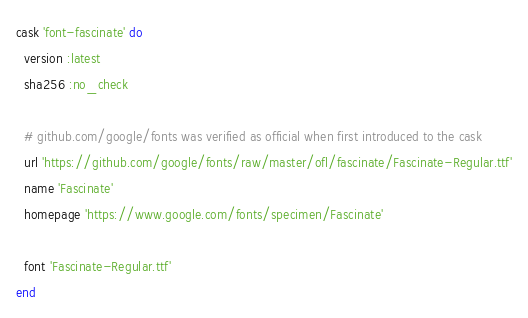<code> <loc_0><loc_0><loc_500><loc_500><_Ruby_>cask 'font-fascinate' do
  version :latest
  sha256 :no_check

  # github.com/google/fonts was verified as official when first introduced to the cask
  url 'https://github.com/google/fonts/raw/master/ofl/fascinate/Fascinate-Regular.ttf'
  name 'Fascinate'
  homepage 'https://www.google.com/fonts/specimen/Fascinate'

  font 'Fascinate-Regular.ttf'
end
</code> 